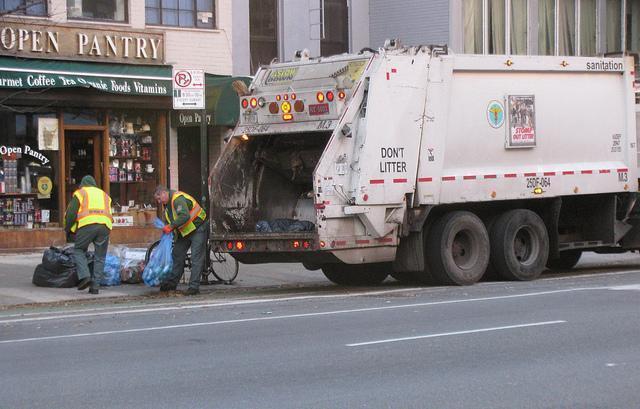Why are the men wearing yellow vests?
Choose the right answer from the provided options to respond to the question.
Options: As punishment, for fun, visibility, fashion. Visibility. Why are the men's vests yellow in color?
Indicate the correct response and explain using: 'Answer: answer
Rationale: rationale.'
Options: Fashion, dress code, visibility, camouflage. Answer: visibility.
Rationale: Garbage men are wearing brightly colored vests. roadworkers wear brightly colored clothes to increase visibility and safety. 